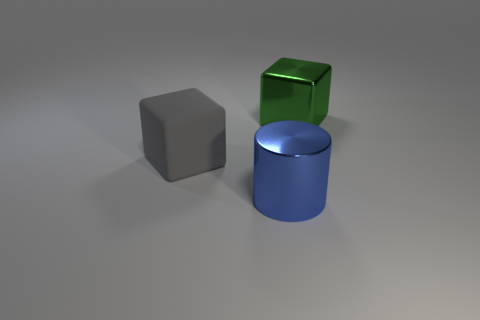Are there any green metallic cubes?
Offer a terse response. Yes. What color is the metallic object that is in front of the matte cube that is behind the blue cylinder that is on the left side of the large green metallic thing?
Keep it short and to the point. Blue. Are there the same number of things that are to the right of the shiny cylinder and matte things that are left of the gray rubber cube?
Your answer should be very brief. No. There is a matte thing that is the same size as the metallic block; what is its shape?
Provide a short and direct response. Cube. Is there another metallic cylinder that has the same color as the large cylinder?
Ensure brevity in your answer.  No. There is a big thing right of the large blue shiny object; what is its shape?
Give a very brief answer. Cube. What color is the large matte cube?
Ensure brevity in your answer.  Gray. The large block that is the same material as the big blue thing is what color?
Offer a very short reply. Green. What number of other cylinders have the same material as the cylinder?
Make the answer very short. 0. How many big cylinders are left of the shiny block?
Your response must be concise. 1. 